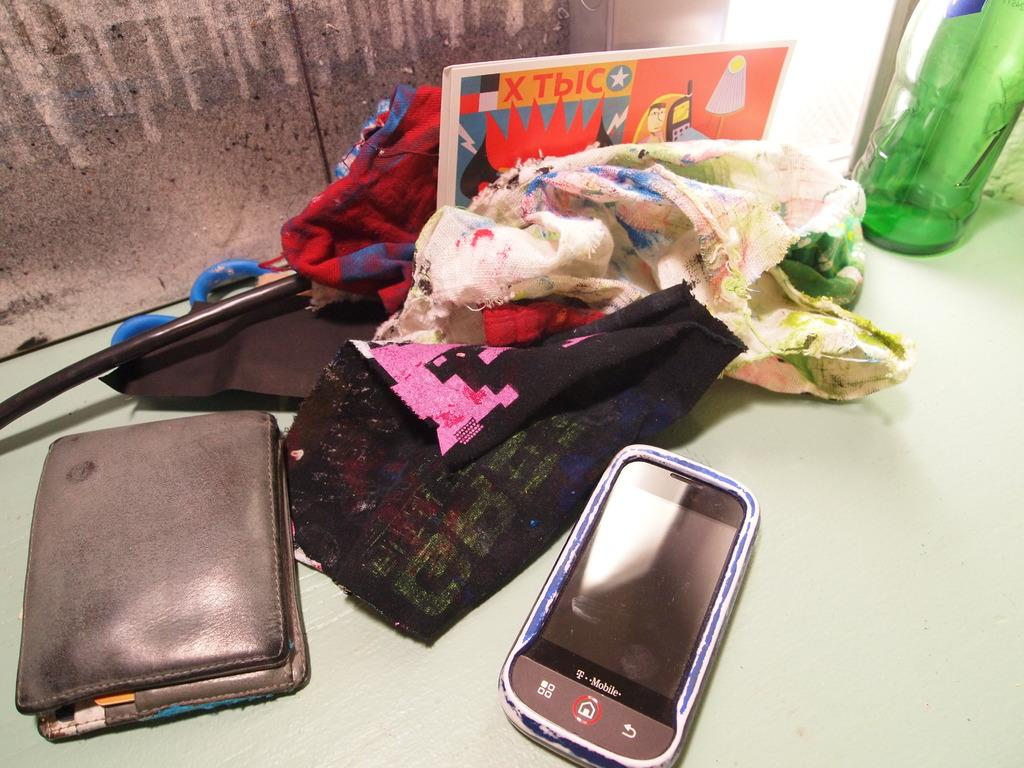What type of objects can be seen in the image? There are cloth pieces, a mobile phone, and a wallet in the image. Can you describe the mobile phone in the image? The mobile phone is one of the objects visible in the image. What else is present in the image besides the mobile phone? There are cloth pieces and a wallet in the image. What type of corn can be seen growing in the image? There is no corn present in the image; it features cloth pieces, a mobile phone, and a wallet. Can you describe the laborer working in the image? There is no laborer present in the image; it only features cloth pieces, a mobile phone, and a wallet. 